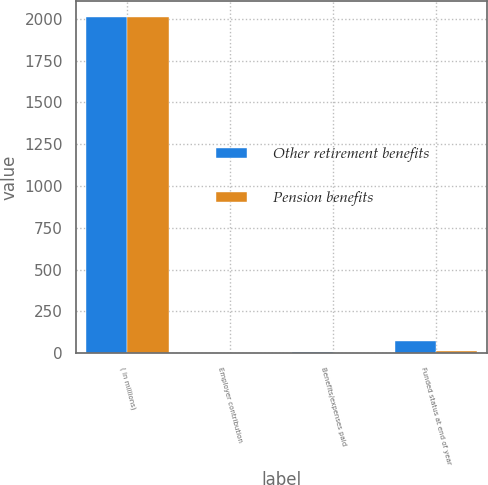Convert chart to OTSL. <chart><loc_0><loc_0><loc_500><loc_500><stacked_bar_chart><ecel><fcel>( in millions)<fcel>Employer contribution<fcel>Benefits/expenses paid<fcel>Funded status at end of year<nl><fcel>Other retirement benefits<fcel>2008<fcel>2.4<fcel>10.1<fcel>73<nl><fcel>Pension benefits<fcel>2008<fcel>0.3<fcel>0.7<fcel>15<nl></chart> 